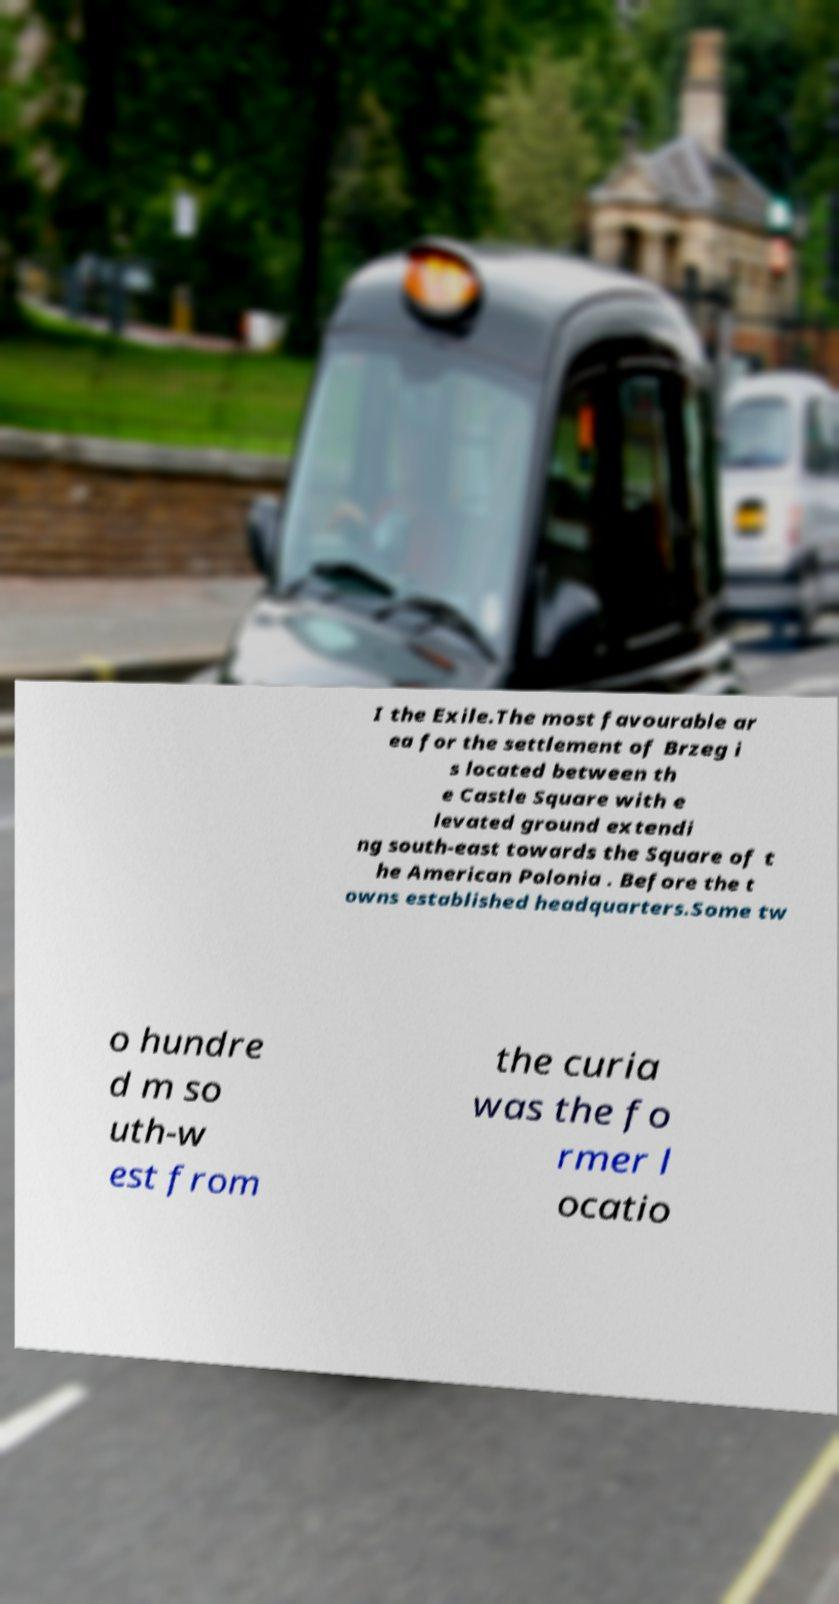For documentation purposes, I need the text within this image transcribed. Could you provide that? I the Exile.The most favourable ar ea for the settlement of Brzeg i s located between th e Castle Square with e levated ground extendi ng south-east towards the Square of t he American Polonia . Before the t owns established headquarters.Some tw o hundre d m so uth-w est from the curia was the fo rmer l ocatio 